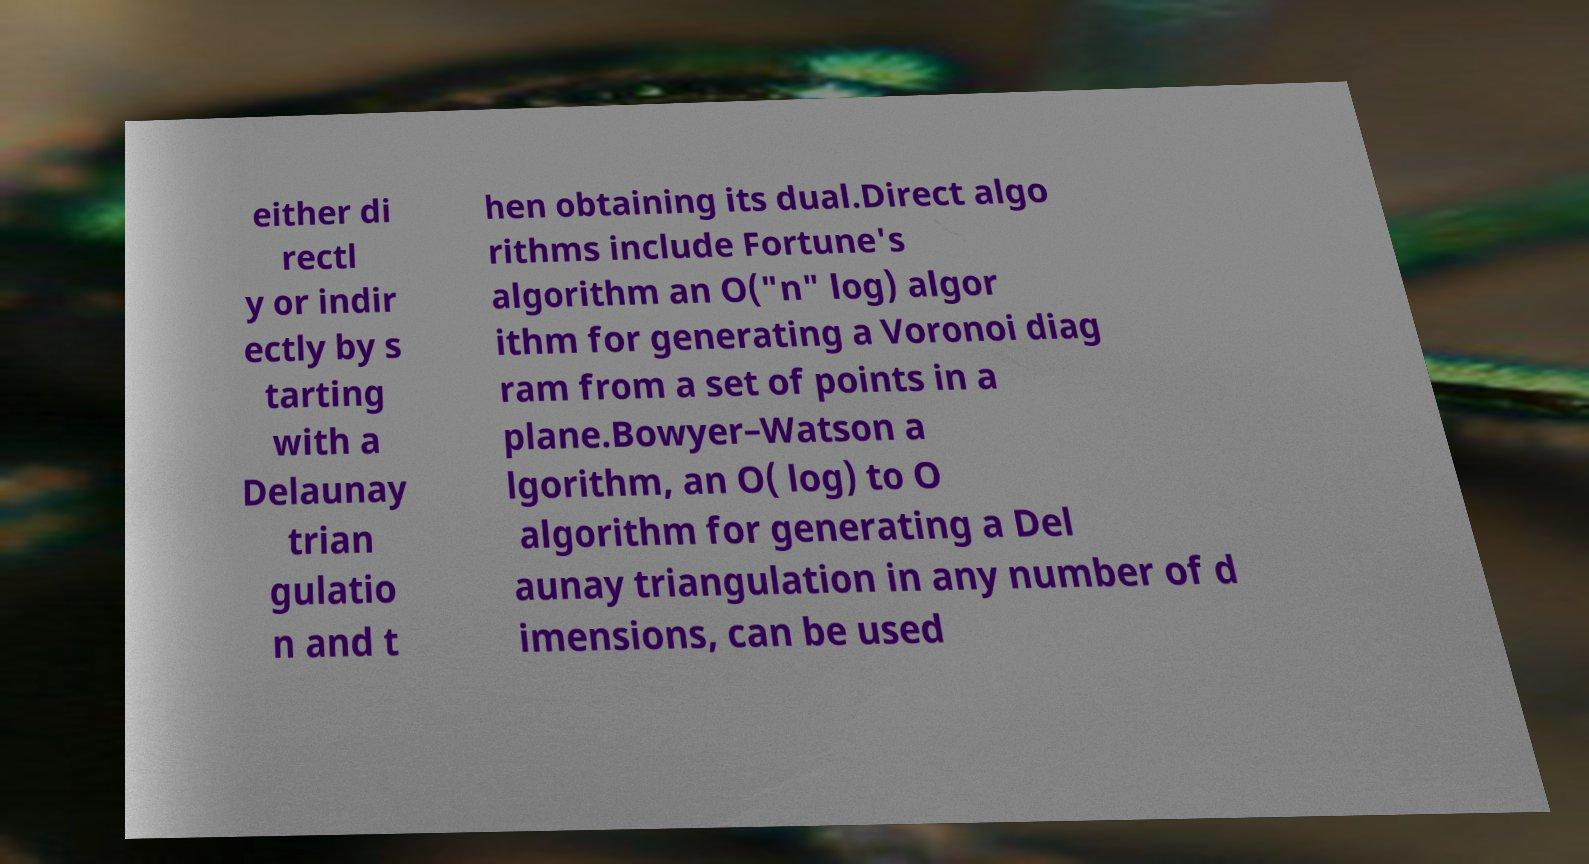Please read and relay the text visible in this image. What does it say? either di rectl y or indir ectly by s tarting with a Delaunay trian gulatio n and t hen obtaining its dual.Direct algo rithms include Fortune's algorithm an O("n" log) algor ithm for generating a Voronoi diag ram from a set of points in a plane.Bowyer–Watson a lgorithm, an O( log) to O algorithm for generating a Del aunay triangulation in any number of d imensions, can be used 